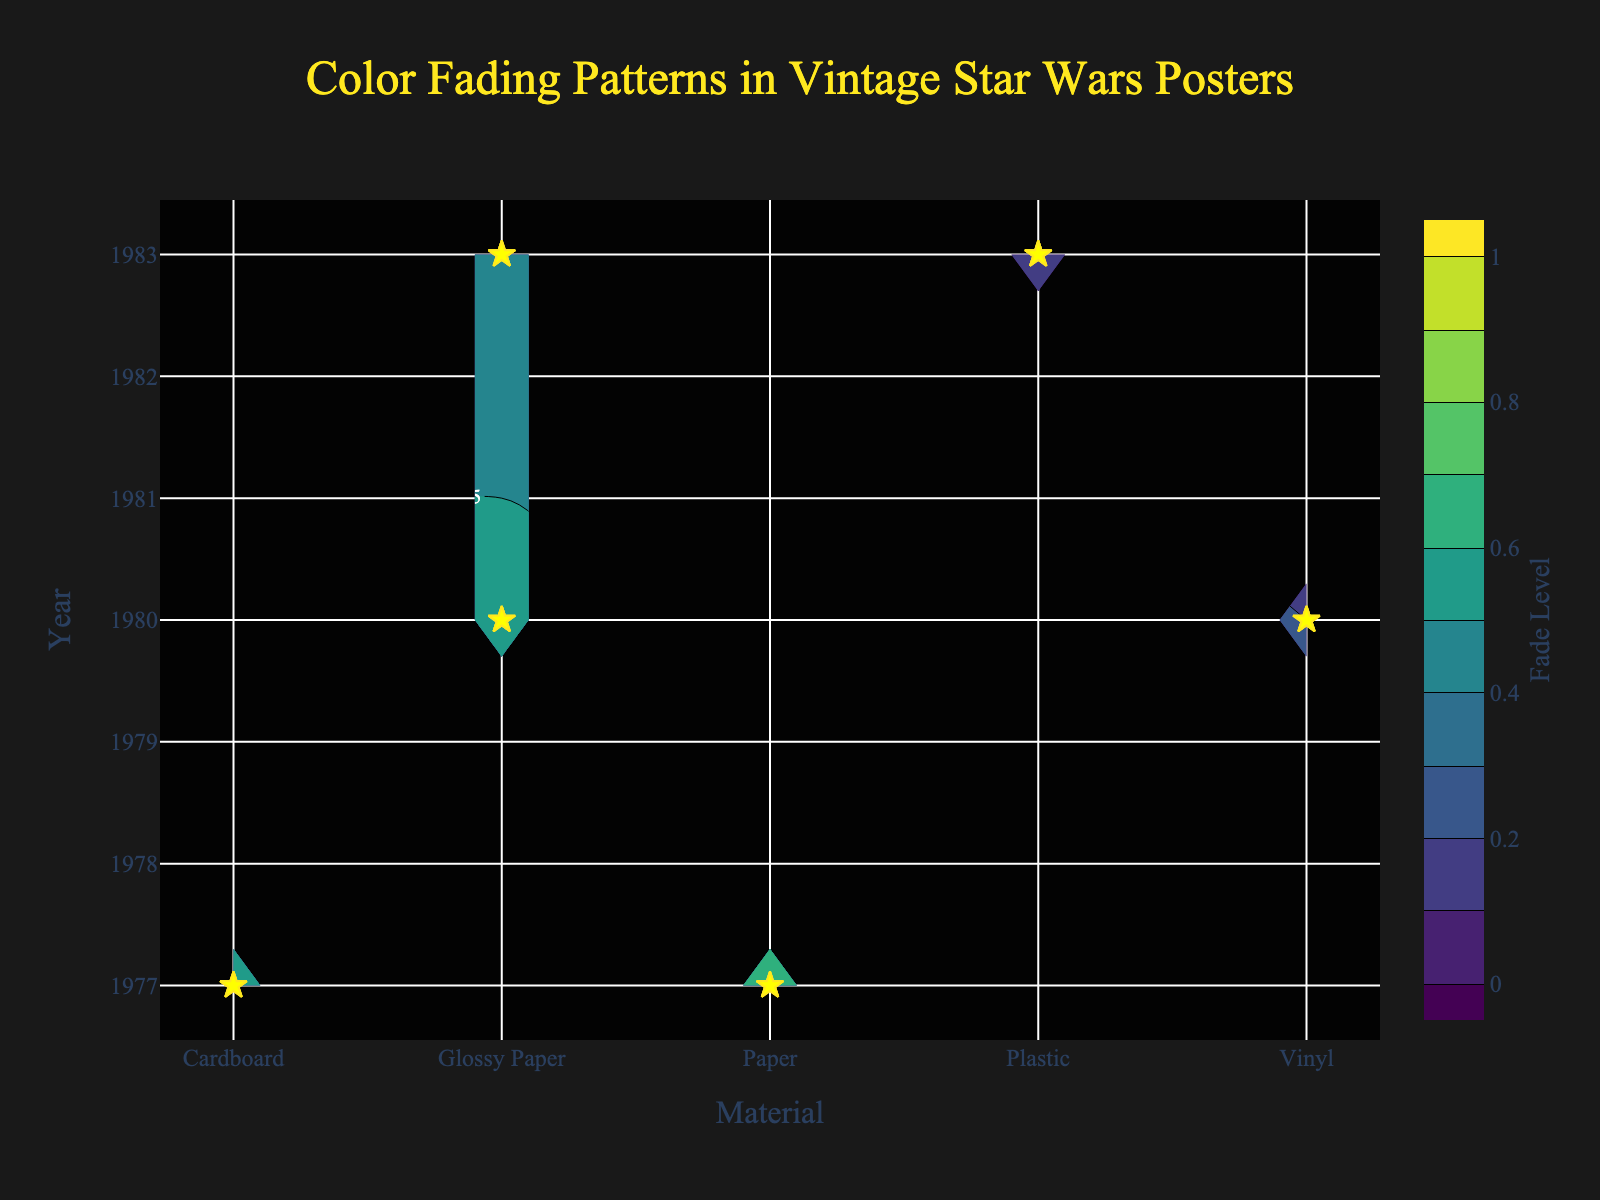What is the title of the figure? The title of the figure is generally displayed prominently at the top of the chart. In this case, the value of the title attribute is 'Color Fading Patterns in Vintage Star Wars Posters'.
Answer: Color Fading Patterns in Vintage Star Wars Posters Which material has the highest fade level in 1977? By looking at the figure, you need to find the highest fade level along the contour plot close to the year 1977. In the plot, the highest fade level for 1977 is 0.8 for Paper material.
Answer: Paper What is the fade level of Blue color for Glossy Paper in 1983? Locate Glossy Paper on the x-axis and move up to the year 1983 along the y-axis. The scatter points or contour labels should show the fade level for Blue color, which is 0.4.
Answer: 0.4 Which material showed the lowest fade level in 1980 and what was that level? By analyzing the contour plot and scatter points for the year 1980, identify the material with the lowest fade level. Vinyl has the lowest fade level at 0.1 in 1980.
Answer: Vinyl, 0.1 Comparing the fade levels, was the Red color's fade more severe in Paper or Cardboard in 1977? Check the fade level associated with Red color for both Paper and Cardboard materials in the year 1977 on the contour plot. Paper has a fade level of 0.8, while Cardboard has a fade level of 0.6, making Paper's fade more severe.
Answer: Paper What is the average fade level of Yellow color across all materials in 1980? Extract and average the fade levels for Yellow color in all materials in 1980: Glossy Paper (0.4), Vinyl (0.1). The average is (0.4 + 0.1) / 2 = 0.25.
Answer: 0.25 Which material shows the greatest improvement in fade resistance from 1977 to 1983? Find the biggest reduction in fade levels from 1977 to 1983. Compare the fade levels for each material in both years and identify which one has the most significant decrease. Paper (0.8 to 0.6), Cardboard (0.6 to omitted), Glossy Paper (omitted to 0.6), Plastic (omitted to 0.1). Paper and Plastic show the greatest improvements but only Paper's values are mentioned clearly from 1977 to 1983.
Answer: Paper How does the fade level for Yellow compare between Cardboard in 1977 and Plastic in 1983? Evaluate the fade level for Yellow in the years 1977 and 1983 for both materials on the contour plot. Cardboard in 1977 has a fade level of 0.4, while Plastic in 1983 has a fade level of 0.1, making Plastic show less fading.
Answer: Plastic's fade level is lower Is there a trend in color fade levels over the years for Glossy Paper? By observing the contours and scatter points for Glossy Paper across different years, determine if fade levels are increasing, decreasing, or stable over time. Glossy Paper shows slightly decreasing fade levels from 0.7 in 1980 to 0.6 in 1983.
Answer: Decreasing What are the colors used for the x-axis, y-axis, and contour labels in the plot? The colors of the axis labels and contours are specified within a given style attribute, refer to their use of simple and bold colors. The x-axis, y-axis, and contour labels are styled in white, as seen in the figure.
Answer: White 